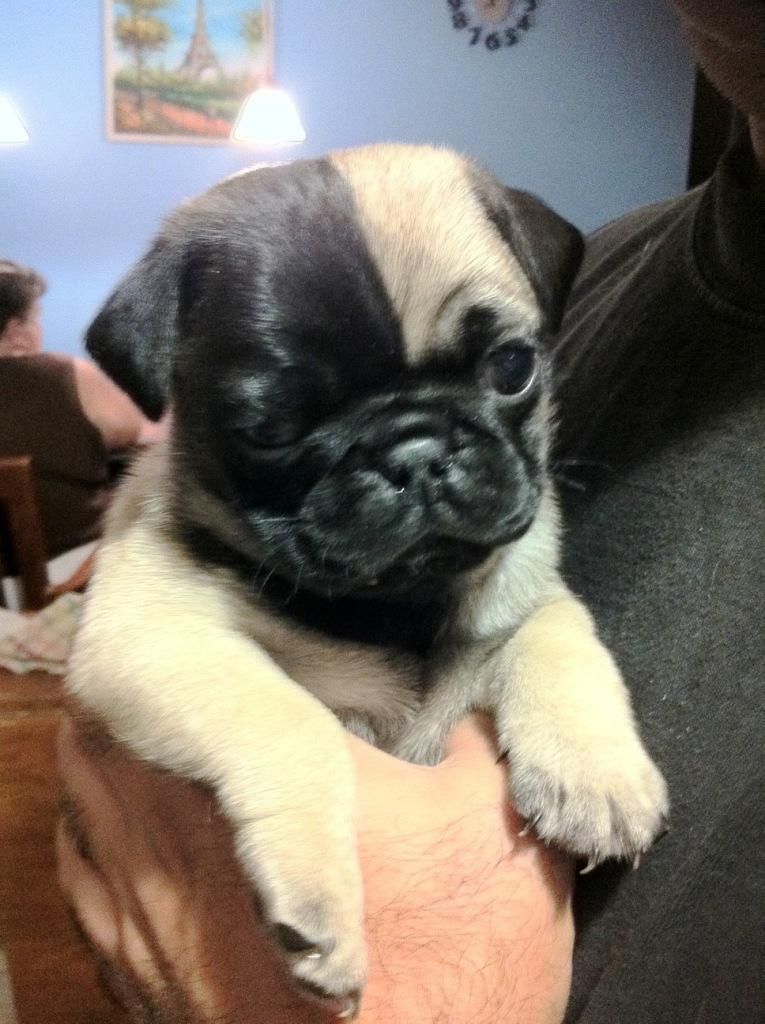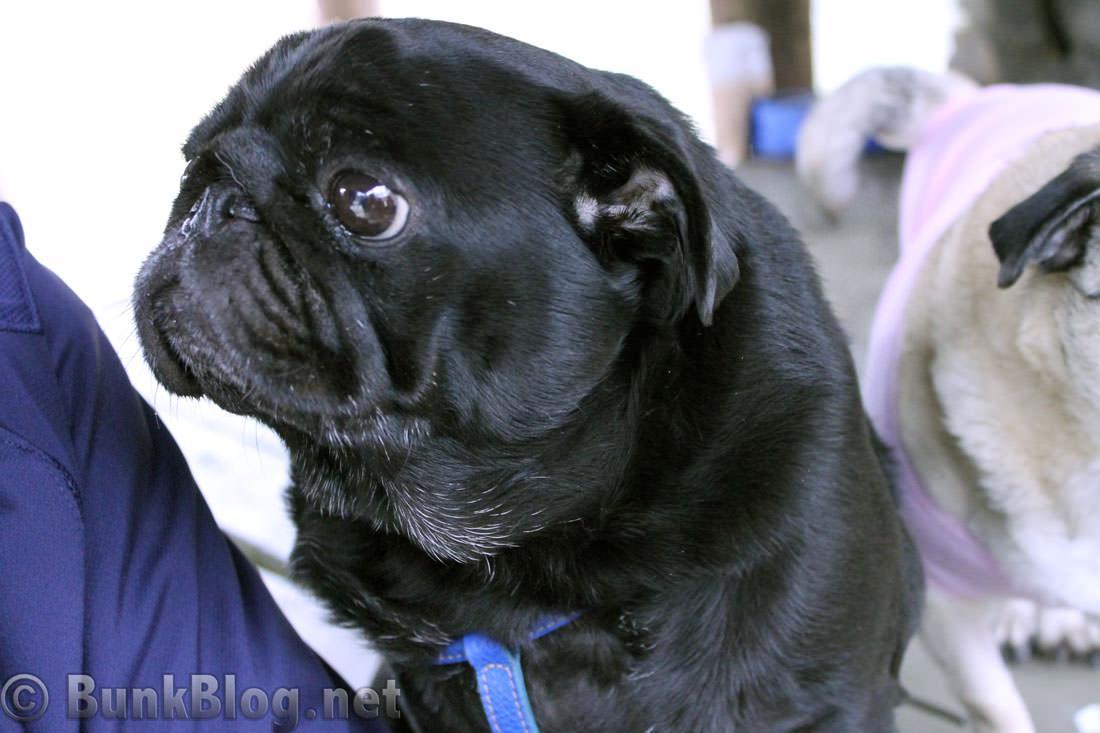The first image is the image on the left, the second image is the image on the right. Analyze the images presented: Is the assertion "There is a pug lying on its back in the left image." valid? Answer yes or no. No. 